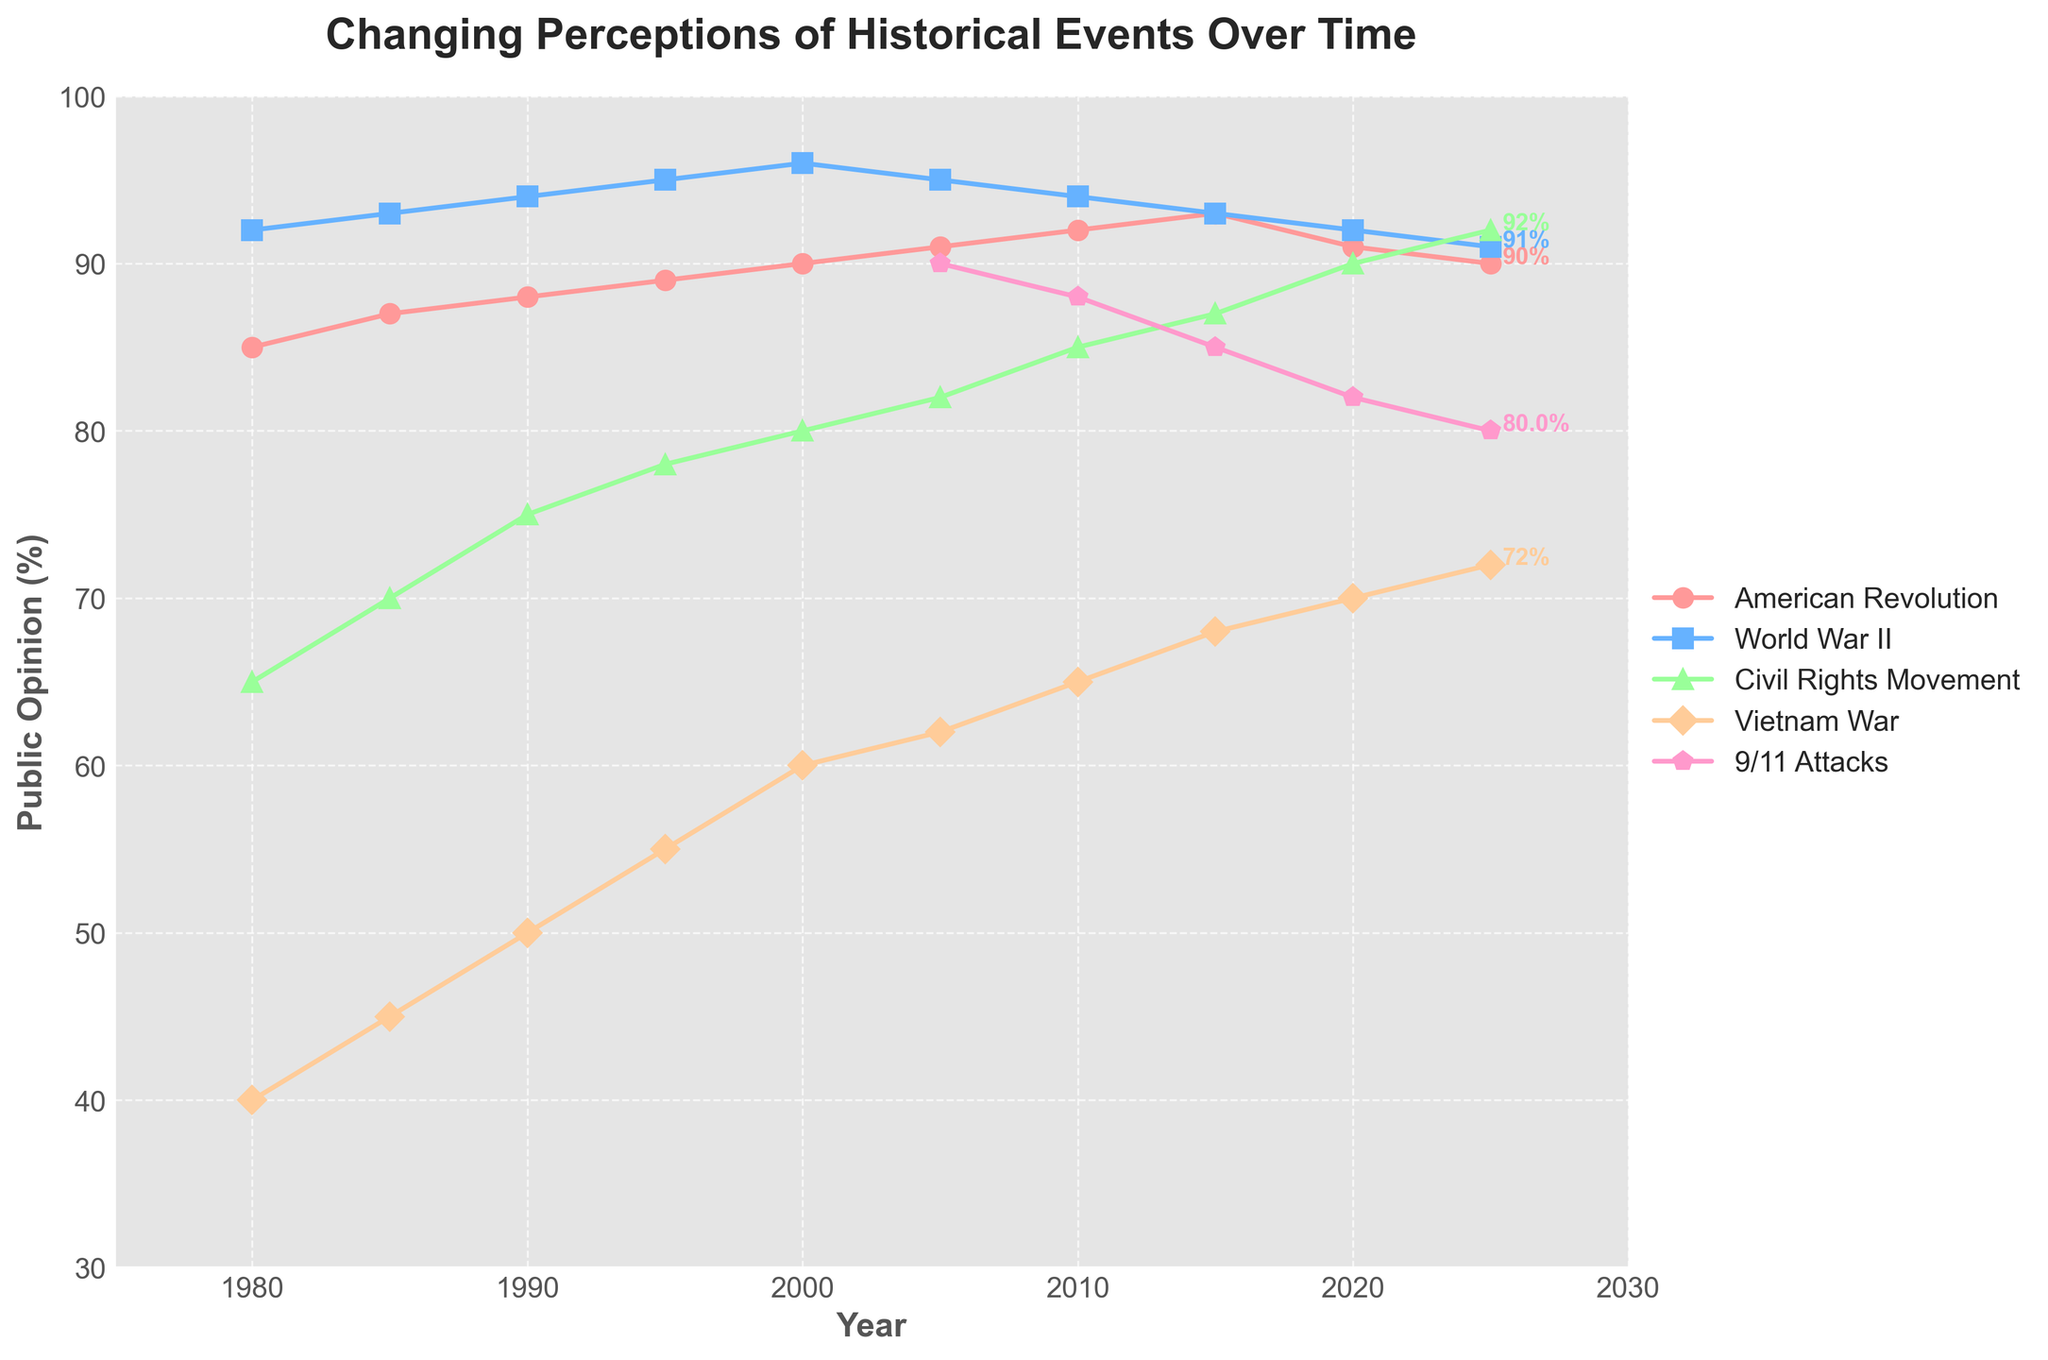What's the highest public opinion percentage for any historical event in 2005? Look for the highest point among the different lines in the year 2005. The highest percentage is for World War II.
Answer: 95% Between 1990 and 2025, which historical event showed the highest increase in public opinion percentage? Calculate the difference in percentages for each event between 1990 and 2025. The Civil Rights Movement shows the highest increase (92% - 75% = 17%).
Answer: Civil Rights Movement How did public opinion of the 9/11 Attacks change from 2005 to 2025? Observe the data points for the 9/11 Attacks from 2005 (90%) to 2025 (80%). It shows a decrease.
Answer: It decreased by 10% Which historical event had the most stable public opinion percentage between 1980 and 2025? Examine the lines for fluctuations over time, focusing on the range of percentages. The American Revolution shows the least fluctuation (range of only 8%).
Answer: American Revolution In which year did the Vietnam War reach 65% in public opinion? Locate the point where the Vietnam War line reaches 65%, which happens in the year 2010.
Answer: 2010 Compare the public opinion of World War II and the Vietnam War in 1995. Which had more support? Find the data points for both World War II (95%) and the Vietnam War (55%) in 1995 and compare them.
Answer: World War II had more support at 95% Which historical event had the greatest drop in public opinion from 2010 to 2020? Calculate the decrease for each event between 2010 and 2020. 9/11 Attacks decreased from 88% to 82%.
Answer: 9/11 Attacks During which period did the Civil Rights Movement see its highest rate of increase in public opinion? Observe the slope of the Civil Rights Movement line. The steepest segment appears between 1995 and 2005 (from 78% to 82%).
Answer: 1995 to 2005 What is the average public opinion of the Vietnam War from 1980 to 2025? Sum the public opinion percentages of the Vietnam War across the given years and divide by the count of years (40+45+50+55+60+62+65+68+70+72)/10 = 58.7
Answer: 58.7 Compare the public opinion percentages of World War II and the Civil Rights Movement in 2020. How much is the difference? Subtract the percentage of the Civil Rights Movement (90%) from World War II (92%) in 2020.
Answer: 2% 